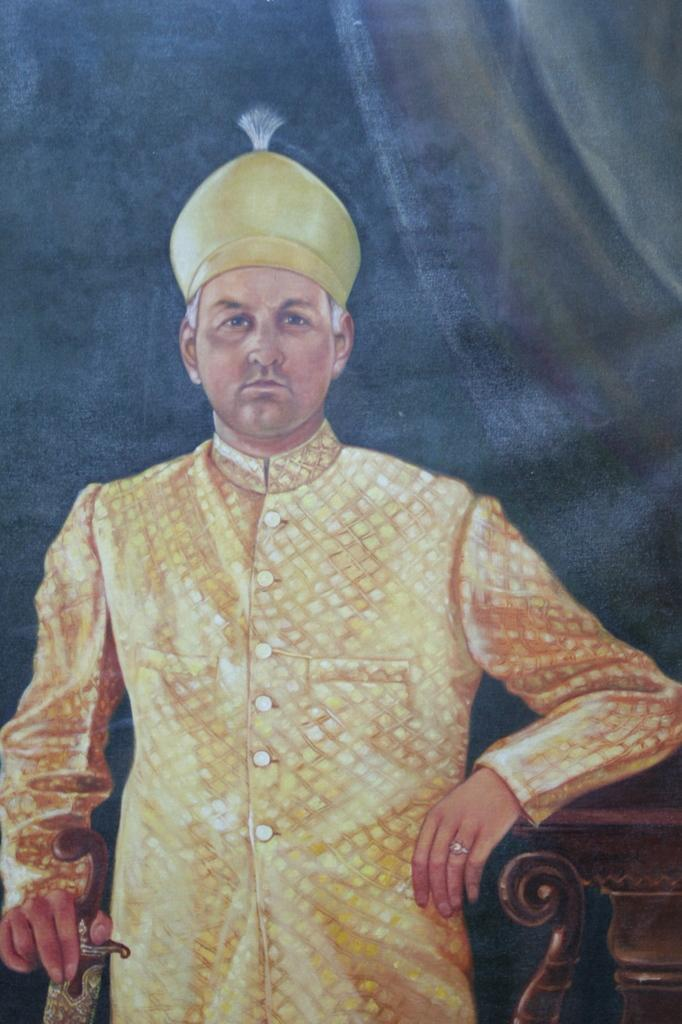What is the main subject of the image? There is a person standing in the image. What can be seen on the person in the image? Clothing is visible in the image. What else is present in the image besides the person? There appears to be a poster in the image. What type of brick is being used to construct the side of the building in the image? There is no building or brick visible in the image; it only features a person and a poster. 